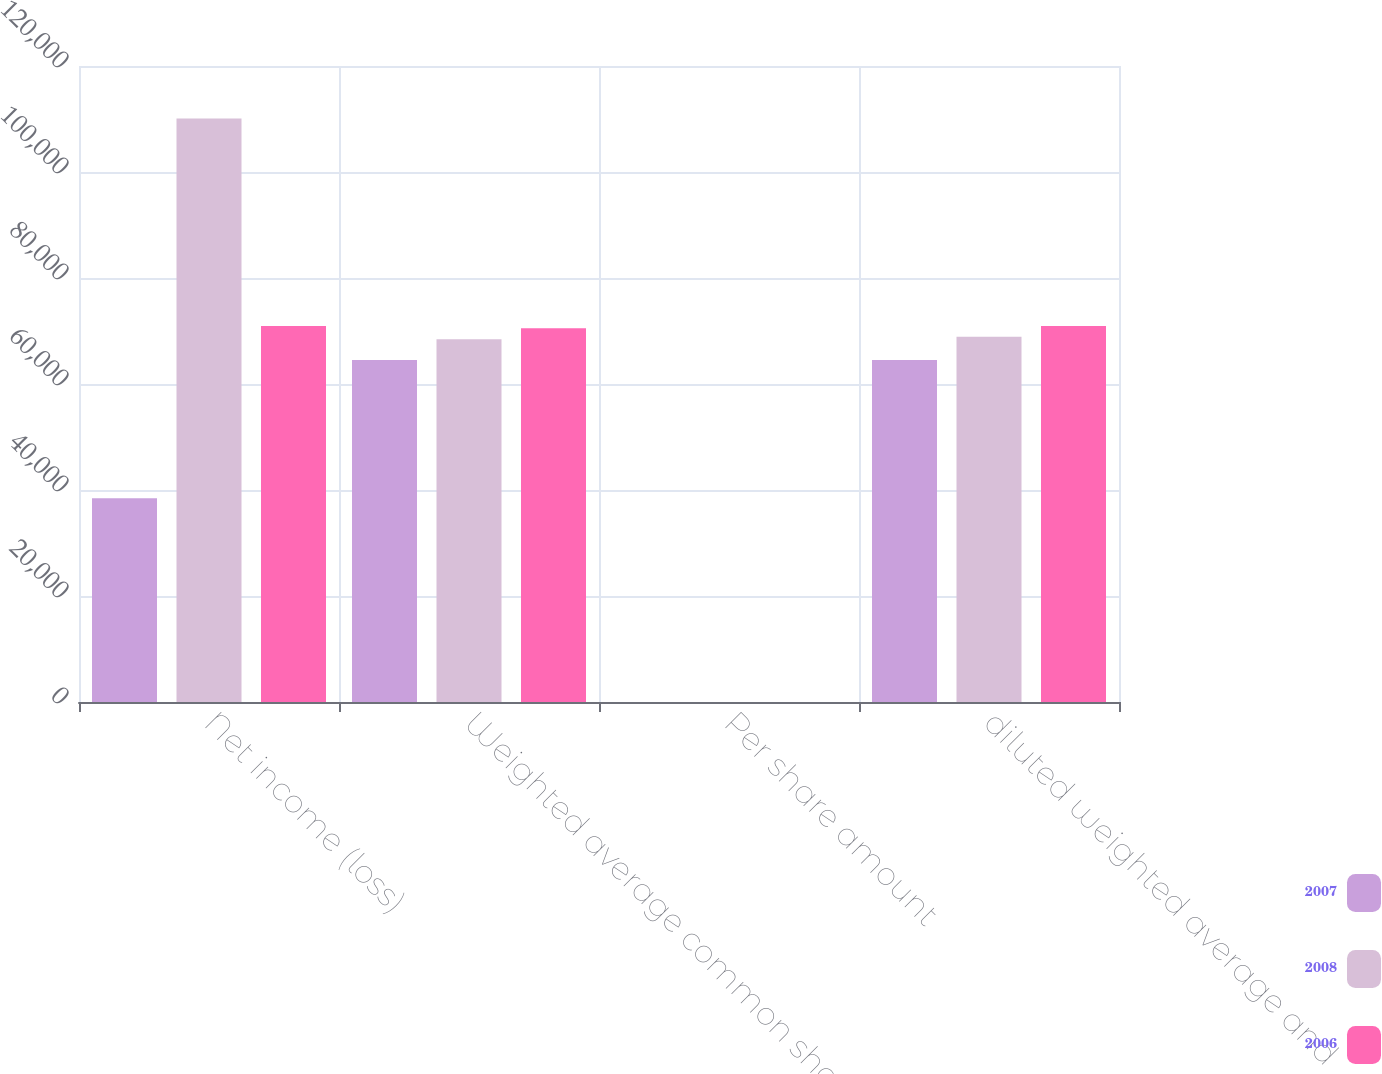<chart> <loc_0><loc_0><loc_500><loc_500><stacked_bar_chart><ecel><fcel>Net income (loss)<fcel>Weighted average common shares<fcel>Per share amount<fcel>diluted weighted average and<nl><fcel>2007<fcel>38421<fcel>64524<fcel>0.6<fcel>64524<nl><fcel>2008<fcel>110113<fcel>68463<fcel>1.61<fcel>68908<nl><fcel>2006<fcel>70946<fcel>70516<fcel>1.01<fcel>70956<nl></chart> 